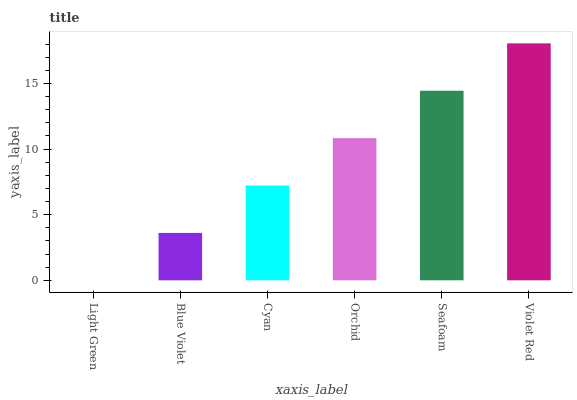Is Blue Violet the minimum?
Answer yes or no. No. Is Blue Violet the maximum?
Answer yes or no. No. Is Blue Violet greater than Light Green?
Answer yes or no. Yes. Is Light Green less than Blue Violet?
Answer yes or no. Yes. Is Light Green greater than Blue Violet?
Answer yes or no. No. Is Blue Violet less than Light Green?
Answer yes or no. No. Is Orchid the high median?
Answer yes or no. Yes. Is Cyan the low median?
Answer yes or no. Yes. Is Violet Red the high median?
Answer yes or no. No. Is Violet Red the low median?
Answer yes or no. No. 